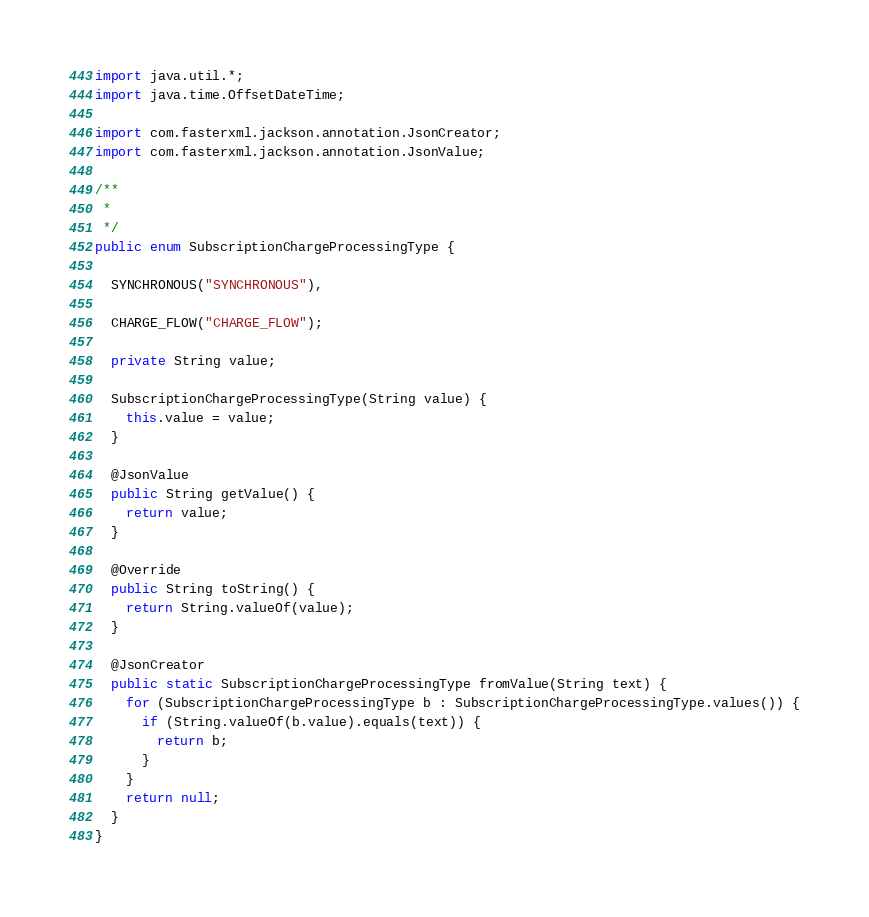<code> <loc_0><loc_0><loc_500><loc_500><_Java_>import java.util.*;
import java.time.OffsetDateTime;

import com.fasterxml.jackson.annotation.JsonCreator;
import com.fasterxml.jackson.annotation.JsonValue;

/**
 * 
 */
public enum SubscriptionChargeProcessingType {
  
  SYNCHRONOUS("SYNCHRONOUS"),
  
  CHARGE_FLOW("CHARGE_FLOW");

  private String value;

  SubscriptionChargeProcessingType(String value) {
    this.value = value;
  }

  @JsonValue
  public String getValue() {
    return value;
  }

  @Override
  public String toString() {
    return String.valueOf(value);
  }

  @JsonCreator
  public static SubscriptionChargeProcessingType fromValue(String text) {
    for (SubscriptionChargeProcessingType b : SubscriptionChargeProcessingType.values()) {
      if (String.valueOf(b.value).equals(text)) {
        return b;
      }
    }
    return null;
  }
}

</code> 